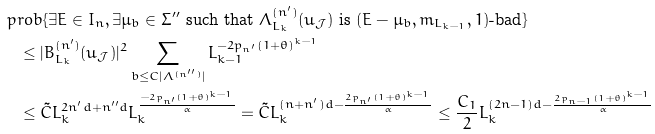Convert formula to latex. <formula><loc_0><loc_0><loc_500><loc_500>& \ p r o b \{ \exists E \in I _ { n } , \exists \mu _ { b } \in \Sigma ^ { \prime \prime } \text { such that } \Lambda _ { L _ { k } } ^ { ( n ^ { \prime } ) } ( u _ { \mathcal { J } } ) \text { is } ( E - \mu _ { b } , m _ { L _ { k - 1 } } , 1 ) \text {-bad} \} \\ & \quad \leq | B _ { L _ { k } } ^ { ( n ^ { \prime } ) } ( u _ { \mathcal { J } } ) | ^ { 2 } \sum _ { b \leq C | \Lambda ^ { ( n ^ { \prime \prime } ) } | } L _ { k - 1 } ^ { - 2 p _ { n ^ { \prime } } ( 1 + \theta ) ^ { k - 1 } } \\ & \quad \leq \tilde { C } L _ { k } ^ { 2 n ^ { \prime } d + n ^ { \prime \prime } d } L _ { k } ^ { \frac { - 2 p _ { n ^ { \prime } } ( 1 + \theta ) ^ { k - 1 } } { \alpha } } = \tilde { C } L _ { k } ^ { ( n + n ^ { \prime } ) d - \frac { 2 p _ { n ^ { \prime } } ( 1 + \theta ) ^ { k - 1 } } { \alpha } } \leq \frac { C _ { 1 } } { 2 } L _ { k } ^ { ( 2 n - 1 ) d - \frac { 2 p _ { n - 1 } ( 1 + \theta ) ^ { k - 1 } } { \alpha } }</formula> 